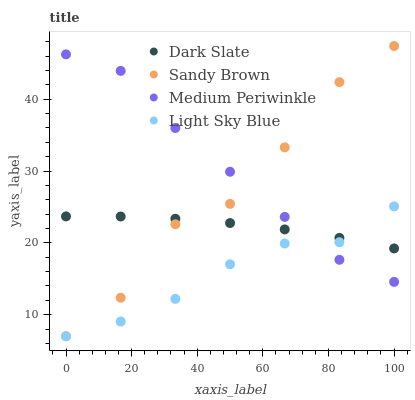Does Light Sky Blue have the minimum area under the curve?
Answer yes or no. Yes. Does Medium Periwinkle have the maximum area under the curve?
Answer yes or no. Yes. Does Sandy Brown have the minimum area under the curve?
Answer yes or no. No. Does Sandy Brown have the maximum area under the curve?
Answer yes or no. No. Is Dark Slate the smoothest?
Answer yes or no. Yes. Is Sandy Brown the roughest?
Answer yes or no. Yes. Is Light Sky Blue the smoothest?
Answer yes or no. No. Is Light Sky Blue the roughest?
Answer yes or no. No. Does Light Sky Blue have the lowest value?
Answer yes or no. Yes. Does Medium Periwinkle have the lowest value?
Answer yes or no. No. Does Sandy Brown have the highest value?
Answer yes or no. Yes. Does Light Sky Blue have the highest value?
Answer yes or no. No. Does Medium Periwinkle intersect Dark Slate?
Answer yes or no. Yes. Is Medium Periwinkle less than Dark Slate?
Answer yes or no. No. Is Medium Periwinkle greater than Dark Slate?
Answer yes or no. No. 